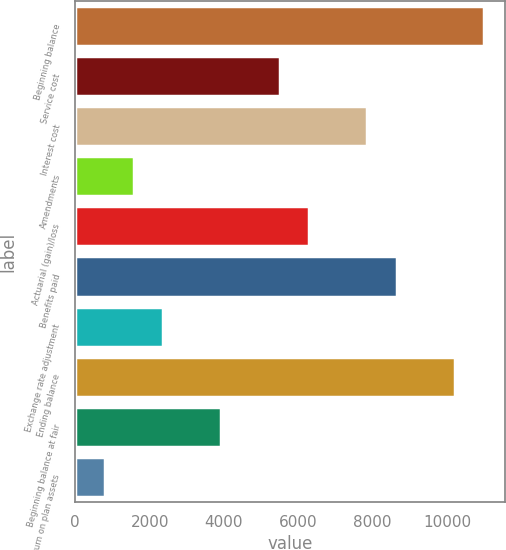Convert chart. <chart><loc_0><loc_0><loc_500><loc_500><bar_chart><fcel>Beginning balance<fcel>Service cost<fcel>Interest cost<fcel>Amendments<fcel>Actuarial (gain)/loss<fcel>Benefits paid<fcel>Exchange rate adjustment<fcel>Ending balance<fcel>Beginning balance at fair<fcel>Actual return on plan assets<nl><fcel>11001.8<fcel>5501.9<fcel>7859<fcel>1573.4<fcel>6287.6<fcel>8644.7<fcel>2359.1<fcel>10216.1<fcel>3930.5<fcel>787.7<nl></chart> 